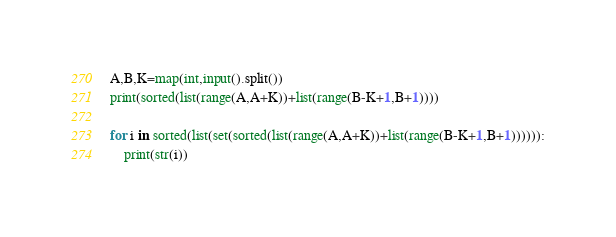Convert code to text. <code><loc_0><loc_0><loc_500><loc_500><_Python_>A,B,K=map(int,input().split())
print(sorted(list(range(A,A+K))+list(range(B-K+1,B+1))))

for i in sorted(list(set(sorted(list(range(A,A+K))+list(range(B-K+1,B+1)))))):
    print(str(i))</code> 